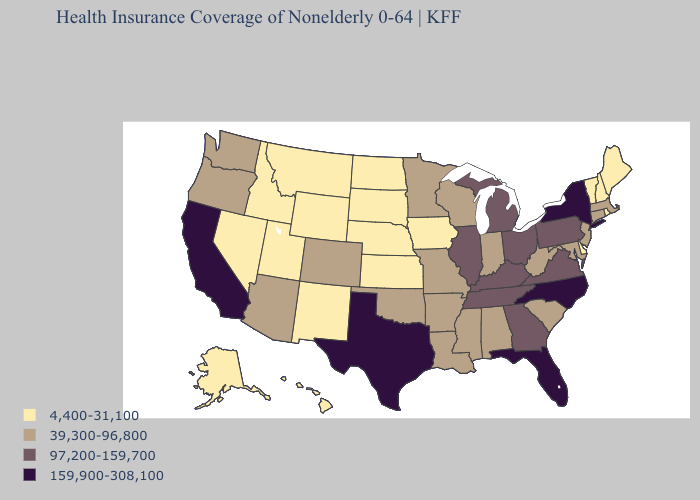Does North Carolina have the lowest value in the USA?
Keep it brief. No. Name the states that have a value in the range 4,400-31,100?
Quick response, please. Alaska, Delaware, Hawaii, Idaho, Iowa, Kansas, Maine, Montana, Nebraska, Nevada, New Hampshire, New Mexico, North Dakota, Rhode Island, South Dakota, Utah, Vermont, Wyoming. What is the lowest value in the West?
Give a very brief answer. 4,400-31,100. How many symbols are there in the legend?
Short answer required. 4. Name the states that have a value in the range 97,200-159,700?
Write a very short answer. Georgia, Illinois, Kentucky, Michigan, Ohio, Pennsylvania, Tennessee, Virginia. What is the value of Michigan?
Keep it brief. 97,200-159,700. What is the highest value in the West ?
Short answer required. 159,900-308,100. What is the value of Louisiana?
Write a very short answer. 39,300-96,800. Which states hav the highest value in the West?
Short answer required. California. What is the lowest value in states that border Nebraska?
Short answer required. 4,400-31,100. What is the value of South Carolina?
Short answer required. 39,300-96,800. Does Delaware have the lowest value in the South?
Answer briefly. Yes. Does Florida have the highest value in the USA?
Answer briefly. Yes. How many symbols are there in the legend?
Quick response, please. 4. Which states have the lowest value in the West?
Quick response, please. Alaska, Hawaii, Idaho, Montana, Nevada, New Mexico, Utah, Wyoming. 